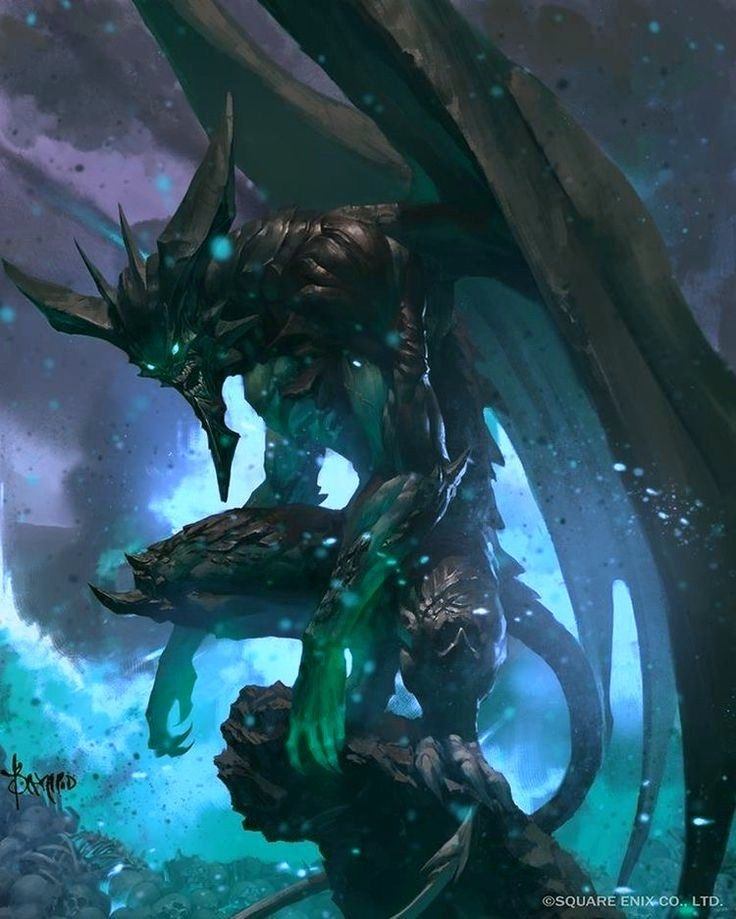the word limit will be 200. describe this image in great detail, including details like the art style, medium, colors, and objects in the image. or anything in the image that you can’t describe normally such as “realism, exquisite realistic, 35mm, realistic texture, 2D anime style, Promotional game Dark Fantasy 2D Digital Painting Illustration, Dark Fantasy 2D Digital Painting Illustration, Dark fantasy, 2D digital, illustration, Dark Fantasy anime manga 2D illustration, WaterColor illustration, watercolor, card game, painterly, copyrighted text, exquisite 2D illustration, anime manga illustration, 2d manga portrait, anime art, manga anime, manwha, female anime portrait, anime sketch art, sketch anime, anime sketch, male manga art, central figure is wearing jacket, brown hair, wet hair, short hair, long hair, female, male, very handsome anime male, handsome male sketch, pinterest anime, pinterest manga anime aesthetic, pinterest manga portrait art, pinterest inspired anime sketch, anything anime, anime manga panel, anime panel, rage anime illustration, bleach anime, sexy hot aesthetic male anime, big boobs, medium boobs, thick thighs, anime wallpaper, gigantic boobs, pinterest manga icons, manga icons, an exquisite digital painting, meticulously crafted, very exquisite, a striking, Young brown skin 18 year old male, the central figure is 18 years old and dark brown skin, dark skin 18 year old, the central figure is dark skin, the central figure is brown skin, young male rapper aesthetic, young 18 year old young man, young man, young woman, young eighteen or twenty year old woman, modern day aesthetic, modern day female rapper aesthetic, long pink lace front hair, female central figure is wearing long lace front hair, extremely big booty, slim waiste with a gigantic booty, female central figure has modern day brazilian butt lift body, large silver chains, shinning large chain necklace, rapper large silver chains, chain accessories, diamond stud earrings, diamond studs, short dread haircut, short teen dread haircut, faded haircut, young man short dread haircut, central figure is wearing gucci, central figure is wearing versace, brown short dread haircut, central figure is wearing versace, central figure is wearing fendi, name brand clothing, extremely handsome face, slim muscular build, shirt off, no shirt at all, central figure has shirt off, gold grillz teeth, silver grillz teeth, extreme handsome face, extremely handsome, defined jawline, male rapper aesthetic, nike sweatshirt, white tank top, rolled up white shirt, modern day sagging pants, big crotch, jeans sagging, holding microphone”. Ideogram is a web application that allows you to browse and generate images from text. Within the user interface, you can generate images, browse and filter previously generated images, curate your user profile, manage your subscription, and more. Here's a little guide that might help you understand prompting on Ideogram, step by step. 
The prompts that will be used will always be written like this:
“A striking portrait of a woman dressed in a sleek, silver-studded black one-piece outfit. The deep V-neckline and cut-out designs on the sides accentuate her figure, while the vibrant pink background adds a pop of color and contrast. Her confident posture and piercing gaze create an air of elegance and power.”
“A stunning, high-fashion portrait of a confident woman wearing a vibrant two-piece outfit. The off-shoulder crop top features a halter neck design with a colorful mesh pattern in hues of red, green, yellow, and black. A bold yellow bow adorns the center of the top. The mini-length skirt matches the top's color scheme, boasting a frilly hem and red borders. The overall effect is bold, modern, and eye-catching, set against a pristine white background.”
“A stunning portrait of a woman in a dazzling two-piece outfit. The top is a vibrant yellow with a white trim, adorned with small rhinestones that catch the light, creating a sparkling effect. The bottom consists of yellow shorts with multiple slits on the sides, also decorated with rhinestones. The woman exudes confidence, her eyes capturing the viewer's attention, standing boldly against a pure white background that accentuates her vibrant attire.”
“A stunning portrait of a woman dressed in a vibrant, fashion-forward two-piece outfit. The halter-style top features a unique crisscross pattern and a bold, metallic circular centerpiece that catches the eye. The ruffled skirt showcases a tie-dye pattern in a harmonious blend of pink, purple, blue, and orange hues. The woman stands confidently against a lush backdrop of green foliage, with a black fence providing a contrasting element to the scene.”
“A captivating, surreal portrait of a woman in profile, showcasing her distinctive features. She dons striking sunglasses and bold makeup, accentuating her beauty. Clad in an alluring, one-piece rhinestone mesh bodysuit with long sleeves, she exudes confidence. A mesmerizing neon green aura surrounds her head, emitting luminous orbs that disperse into the dreamy, muted pink background. This captivating image evokes a sense of otherworldly glamour and mystique.”
“A captivating, avant-garde scene featuring a woman exuding elegance in a dress entirely crafted from 35mm film strips. Each section of the dress is meticulously composed of film strips, with snakes and intertwined patterns creating a visually stunning design. The film strips capture fleeting moments: intimate portraits, dynamic urban landscapes, and abstract details that come to life as the dress moves. Light plays across the shiny surfaces of the film strips, casting bursts of color and constantly changing shadows. The woman wears the dress with natural grace, moving with an elegance that complements the sophistication of the design. Her hair is styled to emphasize the film strips in her dress, highlighting the fusion of visual art and contemporary fashion that it represents. The background is carefully chosen to accentuate the texture and shimmer of the film dress. Soft lights subtly
In a science fiction world of space exploration, we meet Nova, a fearless and determined galactic explorer. Her deep azure skin contrasts with her bright, golden-yellow eyes that reflect the stars of the universe. Nova has short, sharp violet hair with strands that seem like energy streaks. She wears a tight-fitting black spacesuit with electric blue accents, equipped with advanced technology such as integrated solar panels and thrusters for space maneuvers. In her right hand, she holds a holographic exploration device that projects star maps into the air, while a small star-shaped drone by her side assists her in her missions. The background shows a stellar landscape filled with nebulas and brilliant constellations, evoking a sense of vastness and wonder of the outer cosmos.”
“This conceptual artwork masterfully blends natural elegance with futuristic avant-garde aesthetics. The model exudes a magnetic presence as she dons an innovative, metallic insect-inspired ensemble by Givenchy. This outfit embodies the essence of the insect with a design that highlights its iridescent uniqueness and singular beauty.
The high-fashion outfit is a sculpted masterpiece, appearing to be carved from liquid metal, reflecting the iridescence and changing colors of the insect's shell. The dress embraces the curves of the model, with pleats and textures mimicking the bone-like, segmented structures of the metallic insect. The insect's head stands out in the design, with an elegant, curved neckpiece resembling the insect's antennas extending upward. Relief details on the shoulders and chest imitate the insect'.”.
“A captivating illustration of a mystical lotus nymph, elegantly standing in the center of a serene pond. Her gown is a mesmerizing blend of delicate lily pad leaves and vibrant lotus petals, creating a harmonious balance of colors. Her hair, adorned with floating lotus blooms, cascades around her shoulders, while her aquamarine eyes reflect the tranquility of the water. She cradles a lotus bud in her hands, symbolizing new beginnings and spiritual growth. The background is a peaceful reflection of the pond's surface, with soft pastel hues and gentle ripples, immersing the viewer in a world of enchantment and serenity.” 
now you try. remember to update your memory on wide knowledge about everything to ever exist even important information in modern day. Here's a little guide that might help you understand prompting on Ideogram, step by step.  This image is a dark fantasy 2D digital painting. It portrays a grotesque and unsettling scene with a central figure that appears to be a nightmarish jester or clown. The jester has a pale, skeletal frame, wearing a torn, harlequin-patterned hat. His face is covered with a mask that has a sinister, toothy grin. He holds a baby with a distressed expression in one hand and a large bone-like club in the other. The jester's elongated fingers and sharp nails enhance his menacing appearance.

Behind him, a large, mechanical scythe-like apparatus looms, adding to the eerie atmosphere. The background is awash with dark, fiery reds and browns, creating a hellish and chaotic environment. The art style is highly detailed and realistic, with a focus on creating a disturbing and surreal visual impact. The textures and colors emphasize the dark and morbid theme, making the overall composition haunting and intense. the word limit will be 200. describe this image in great detail, including details like the art style, medium, colors, and objects in the image. or anything in the image that you can’t describe normally such as “realism, exquisite realistic, 35mm, realistic texture, 2D anime style, Promotional game Dark Fantasy 2D Digital Painting Illustration, Dark Fantasy 2D Digital Painting Illustration, Dark fantasy, 2D digital, illustration, Dark Fantasy anime manga 2D illustration, WaterColor illustration, watercolor, card game, painterly, copyrighted text, exquisite 2D illustration, anime manga illustration, 2d manga portrait, anime art, manga anime, manwha, female anime portrait, anime sketch art, sketch anime, anime sketch, male manga art, central figure is wearing jacket, brown hair, wet hair, short hair, long hair, female, male, very handsome anime male, handsome male sketch, pinterest anime, pinterest manga anime aesthetic, pinterest manga portrait art, pinterest inspired anime sketch, anything anime, anime manga panel, anime panel, rage anime illustration, bleach anime, sexy hot aesthetic male anime, big boobs, medium boobs, thick thighs, anime wallpaper, gigantic boobs, pinterest manga icons, manga icons, an exquisite digital painting, meticulously crafted, very exquisite, a striking, Young brown skin 18 year old male, the central figure is 18 years old and dark brown skin, dark skin 18 year old, the central figure is dark skin, the central figure is brown skin, young male rapper aesthetic, young 18 year old young man, young man, young woman, young eighteen or twenty year old woman, modern day aesthetic, modern day female rapper aesthetic, long pink lace front hair, female central figure is wearing long lace front hair, extremely big booty, slim waiste with a gigantic booty, female central figure has modern day brazilian butt lift body, large silver chains, shinning large chain necklace, rapper large silver chains, chain accessories, diamond stud earrings, diamond studs, short dread haircut, short teen dread haircut, faded haircut, young man short dread haircut, central figure is wearing gucci, central figure is wearing versace, brown short dread haircut, central figure is wearing versace, central figure is wearing fendi, name brand clothing, extremely handsome face, slim muscular build, shirt off, no shirt at all, central figure has shirt off, gold grillz teeth, silver grillz teeth, extreme handsome face, extremely handsome, defined jawline, male rapper aesthetic, nike sweatshirt, white tank top, rolled up white shirt, modern day sagging pants, big crotch, jeans sagging, holding microphone”. Ideogram is a web application that allows you to browse and generate images from text. Within the user interface, you can generate images, browse and filter previously generated images, curate your user profile, manage your subscription, and more. Here's a little guide that might help you understand prompting on Ideogram, step by step. 
The prompts that will be used will always be written like this:
“A striking portrait of a woman dressed in a sleek, silver-studded black one-piece outfit. The deep V-neckline and cut-out designs on the sides accentuate her figure, while the vibrant pink background adds a pop of color and contrast. Her confident posture and piercing gaze create an air of elegance and power.”
“A stunning, high-fashion portrait of a confident woman wearing a vibrant two-piece outfit. The off-shoulder crop top features a halter neck design with a colorful mesh pattern in hues of red, green, yellow, and black. A bold yellow bow adorns the center of the top. The mini-length skirt matches the top's color scheme, boasting a frilly hem and red borders. The overall effect is bold, modern, and eye-catching, set against a pristine white background.”
“A stunning portrait of a woman in a dazzling two-piece outfit. The top is a vibrant yellow with a white trim, adorned with small rhinestones that catch the light, creating a sparkling effect. The bottom consists of yellow shorts with multiple slits on the sides, also decorated with rhinestones. The woman exudes confidence, her eyes capturing the viewer's attention, standing boldly against a pure white background that accentuates her vibrant attire.”
“A stunning portrait of a woman dressed in a vibrant, fashion-forward two-piece outfit. The halter-style top features a unique crisscross pattern and a bold, metallic circular centerpiece that catches the eye. The ruffled skirt showcases a tie-dye pattern in a harmonious blend of pink, purple, blue, and orange hues. The woman stands confidently against a lush backdrop of green foliage, with a black fence providing a contrasting element to the scene.”
“A captivating, surreal portrait of a woman in profile, showcasing her distinctive features. She dons striking sunglasses and bold makeup, accentuating her beauty. Clad in an alluring, one-piece rhinestone mesh bodysuit with long sleeves, she exudes confidence. A mesmerizing neon green aura surrounds her head, emitting luminous orbs that disperse into the dreamy, muted pink background. This captivating image evokes a sense of otherworldly glamour and mystique.”
“A captivating, avant-garde scene featuring a woman exuding elegance in a dress entirely crafted from 35mm film strips. Each section of the dress is meticulously composed of film strips, with snakes and intertwined patterns creating a visually stunning design. The film strips capture fleeting moments: intimate portraits, dynamic urban landscapes, and abstract details that come to life as the dress moves. Light plays across the shiny surfaces of the film strips, casting bursts of color and constantly changing shadows. The woman wears the dress with natural grace, moving with an elegance that complements the sophistication of the design. Her hair is styled to emphasize the film strips in her dress, highlighting the fusion of visual art and contemporary fashion that it represents. The background is carefully chosen to accentuate the texture and shimmer of the film dress. Soft lights subtly
In a science fiction world of space exploration, we meet Nova, a fearless and determined galactic explorer. Her deep azure skin contrasts with her bright, golden-yellow eyes that reflect the stars of the universe. Nova has short, sharp violet hair with strands that seem like energy streaks. She wears a tight-fitting black spacesuit with electric blue accents, equipped with advanced technology such as integrated solar panels and thrusters for space maneuvers. In her right hand, she holds a holographic exploration device that projects star maps into the air, while a small star-shaped drone by her side assists her in her missions. The background shows a stellar landscape filled with nebulas and brilliant constellations, evoking a sense of vastness and wonder of the outer cosmos.”
“This conceptual artwork masterfully blends natural elegance with futuristic avant-garde aesthetics. The model exudes a magnetic presence as she dons an innovative, metallic insect-inspired ensemble by Givenchy. This outfit embodies the essence of the insect with a design that highlights its iridescent uniqueness and singular beauty.
The high-fashion outfit is a sculpted masterpiece, appearing to be carved from liquid metal, reflecting the iridescence and changing colors of the insect's shell. The dress embraces the curves of the model, with pleats and textures mimicking the bone-like, segmented structures of the metallic insect. The insect's head stands out in the design, with an elegant, curved neckpiece resembling the insect's antennas extending upward. Relief details on the shoulders and chest imitate the insect'.”.
“A captivating illustration of a mystical lotus nymph, elegantly standing in the center of a serene pond. Her gown is a mesmerizing blend of delicate lily pad leaves and vibrant lotus petals, creating a harmonious balance of colors. Her hair, adorned with floating lotus blooms, cascades around her shoulders, while her aquamarine eyes reflect the tranquility of the water. She cradles a lotus bud in her hands, symbolizing new beginnings and spiritual growth. The background is a peaceful reflection of the pond's surface, with soft pastel hues and gentle ripples, immersing the viewer in a world of enchantment and serenity.” 
now you try. remember to update your memory on wide knowledge about everything to ever exist even important information in modern day. Here's a little guide that might help you understand prompting on Ideogram, step by step.  This image is a stunning example of dark fantasy 2D digital painting. It features a striking, spectral horse with an ethereal presence. The horse’s mane is long, flowing, and translucent, blending seamlessly into the misty, pastel-colored background. The creature’s coat is an exquisite blend of deep grays and blacks, with subtle hints of purple and blue, giving it a ghostly, otherworldly appearance.

The horse's eyes are a vivid, glowing red, adding a touch of eerie intensity and otherworldliness to its gaze. A delicate branch with clusters of bright red berries dangles from its mouth, providing a stark contrast to the otherwise muted color palette. Wisps of white fog or smoke curl around its head, further enhancing the mystical and surreal atmosphere of the painting.

The overall art style is highly detailed and painterly, with smooth brushstrokes and a soft, dreamlike quality. The use of light and shadow adds depth and dimension, making the horse appear almost lifelike, yet hauntingly unreal. This meticulously crafted illustration evokes a sense of melancholy and enchantment, drawing the viewer into its dark fantasy world. the word limit will be 200. describe this image in great detail, including details like the art style, medium, colors, and objects in the image. or anything in the image that you can’t describe normally such as “realism, exquisite realistic, 35mm, realistic texture, 2D anime style, Promotional game Dark Fantasy 2D Digital Painting Illustration, Dark Fantasy 2D Digital Painting Illustration, Dark fantasy, 2D digital, illustration, Dark Fantasy anime manga 2D illustration, WaterColor illustration, watercolor, card game, painterly, copyrighted text, exquisite 2D illustration, anime manga illustration, 2d manga portrait, anime art, manga anime, manwha, female anime portrait, anime sketch art, sketch anime, anime sketch, male manga art, central figure is wearing jacket, brown hair, wet hair, short hair, long hair, female, male, very handsome anime male, handsome male sketch, pinterest anime, pinterest manga anime aesthetic, pinterest manga portrait art, pinterest inspired anime sketch, anything anime, anime manga panel, anime panel, rage anime illustration, bleach anime, sexy hot aesthetic male anime, big boobs, medium boobs, thick thighs, anime wallpaper, gigantic boobs, pinterest manga icons, manga icons, an exquisite digital painting, meticulously crafted, very exquisite, a striking, Young brown skin 18 year old male, the central figure is 18 years old and dark brown skin, dark skin 18 year old, the central figure is dark skin, the central figure is brown skin, young male rapper aesthetic, young 18 year old young man, young man, young woman, young eighteen or twenty year old woman, modern day aesthetic, modern day female rapper aesthetic, long pink lace front hair, female central figure is wearing long lace front hair, extremely big booty, slim waiste with a gigantic booty, female central figure has modern day brazilian butt lift body, large silver chains, shinning large chain necklace, rapper large silver chains, chain accessories, diamond stud earrings, diamond studs, short dread haircut, short teen dread haircut, faded haircut, young man short dread haircut, central figure is wearing gucci, central figure is wearing versace, brown short dread haircut, central figure is wearing versace, central figure is wearing fendi, name brand clothing, extremely handsome face, slim muscular build, shirt off, no shirt at all, central figure has shirt off, gold grillz teeth, silver grillz teeth, extreme handsome face, extremely handsome, defined jawline, male rapper aesthetic, nike sweatshirt, white tank top, rolled up white shirt, modern day sagging pants, big crotch, jeans sagging, holding microphone”. Ideogram is a web application that allows you to browse and generate images from text. Within the user interface, you can generate images, browse and filter previously generated images, curate your user profile, manage your subscription, and more. Here's a little guide that might help you understand prompting on Ideogram, step by step. 
The prompts that will be used will always be written like this:
“A striking portrait of a woman dressed in a sleek, silver-studded black one-piece outfit. The deep V-neckline and cut-out designs on the sides accentuate her figure, while the vibrant pink background adds a pop of color and contrast. Her confident posture and piercing gaze create an air of elegance and power.”
“A stunning, high-fashion portrait of a confident woman wearing a vibrant two-piece outfit. The off-shoulder crop top features a halter neck design with a colorful mesh pattern in hues of red, green, yellow, and black. A bold yellow bow adorns the center of the top. The mini-length skirt matches the top's color scheme, boasting a frilly hem and red borders. The overall effect is bold, modern, and eye-catching, set against a pristine white background.”
“A stunning portrait of a woman in a dazzling two-piece outfit. The top is a vibrant yellow with a white trim, adorned with small rhinestones that catch the light, creating a sparkling effect. The bottom consists of yellow shorts with multiple slits on the sides, also decorated with rhinestones. The woman exudes confidence, her eyes capturing the viewer's attention, standing boldly against a pure white background that accentuates her vibrant attire.”
“A stunning portrait of a woman dressed in a vibrant, fashion-forward two-piece outfit. The halter-style top features a unique crisscross pattern and a bold, metallic circular centerpiece that catches the eye. The ruffled skirt showcases a tie-dye pattern in a harmonious blend of pink, purple, blue, and orange hues. The woman stands confidently against a lush backdrop of green foliage, with a black fence providing a contrasting element to the scene.”
“A captivating, surreal portrait of a woman in profile, showcasing her distinctive features. She dons striking sunglasses and bold makeup, accentuating her beauty. Clad in an alluring, one-piece rhinestone mesh bodysuit with long sleeves, she exudes confidence. A mesmerizing neon green aura surrounds her head, emitting luminous orbs that disperse into the dreamy, muted pink background. This captivating image evokes a sense of otherworldly glamour and mystique.”
“A captivating, avant-garde scene featuring a woman exuding elegance in a dress entirely crafted from 35mm film strips. Each section of the dress is meticulously composed of film strips, with snakes and intertwined patterns creating a visually stunning design. The film strips capture fleeting moments: intimate portraits, dynamic urban landscapes, and abstract details that come to life as the dress moves. Light plays across the shiny surfaces of the film strips, casting bursts of color and constantly changing shadows. The woman wears the dress with natural grace, moving with an elegance that complements the sophistication of the design. Her hair is styled to emphasize the film strips in her dress, highlighting the fusion of visual art and contemporary fashion that it represents. The background is carefully chosen to accentuate the texture and shimmer of the film dress. Soft lights subtly
In a science fiction world of space exploration, we meet Nova, a fearless and determined galactic explorer. Her deep azure skin contrasts with her bright, golden-yellow eyes that reflect the stars of the universe. Nova has short, sharp violet hair with strands that seem like energy streaks. She wears a tight-fitting black spacesuit with electric blue accents, equipped with advanced technology such as integrated solar panels and thrusters for space maneuvers. In her right hand, she holds a holographic exploration device that projects star maps into the air, while a small star-shaped drone by her side assists her in her missions. The background shows a stellar landscape filled with nebulas and brilliant constellations, evoking a sense of vastness and wonder of the outer cosmos.”
“This conceptual artwork masterfully blends natural elegance with futuristic avant-garde aesthetics. The model exudes a magnetic presence as she dons an innovative, metallic insect-inspired ensemble by Givenchy. This outfit embodies the essence of the insect with a design that highlights its iridescent uniqueness and singular beauty.
The high-fashion outfit is a sculpted masterpiece, appearing to be carved from liquid metal, reflecting the iridescence and changing colors of the insect's shell. The dress embraces the curves of the model, with pleats and textures mimicking the bone-like, segmented structures of the metallic insect. The insect's head stands out in the design, with an elegant, curved neckpiece resembling the insect's antennas extending upward. Relief details on the shoulders and chest imitate the insect'.”.
“A captivating illustration of a mystical lotus nymph, elegantly standing in the center of a serene pond. Her gown is a mesmerizing blend of delicate lily pad leaves and vibrant lotus petals, creating a harmonious balance of colors. Her hair, adorned with floating lotus blooms, cascades around her shoulders, while her aquamarine eyes reflect the tranquility of the water. She cradles a lotus bud in her hands, symbolizing new beginnings and spiritual growth. The background is a peaceful reflection of the pond's surface, with soft pastel hues and gentle ripples, immersing the viewer in a world of enchantment and serenity.” 
now you try. remember to update your memory on wide knowledge about everything to ever exist even important information in modern day. Here's a little guide that might help you understand prompting on Ideogram, step by step.  This image is a dark fantasy 2D digital painting illustration. The central figure is a menacing, otherworldly creature with a demonic appearance. It has a skeletal, armored body with elongated limbs and sharp, claw-like fingers. The creature's head is adorned with large, jagged horns, and its glowing green eyes exude an eerie, malevolent aura. 

The creature appears to be perched on a rocky outcrop, surrounded by a swirling mist of ethereal blue and green hues. The background is filled with dark, stormy clouds and faint, ominous light, enhancing the sense of dread and otherworldliness. The texture of the creature's body is highly detailed, with a realistic, almost metallic sheen that contrasts with the soft, painterly strokes of the mist and background.

The color palette predominantly consists of dark, muted tones, with pops of vibrant green and blue that add a supernatural glow to the scene. The overall composition is dynamic and intense, drawing the viewer's eye to the central figure's piercing gaze and powerful stance. This meticulously crafted painting evokes a sense of dark fantasy and horror, making it a striking and captivating piece of art. 